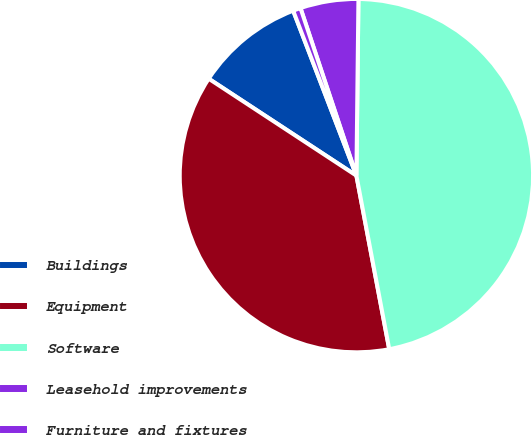<chart> <loc_0><loc_0><loc_500><loc_500><pie_chart><fcel>Buildings<fcel>Equipment<fcel>Software<fcel>Leasehold improvements<fcel>Furniture and fixtures<nl><fcel>9.93%<fcel>37.22%<fcel>46.84%<fcel>5.31%<fcel>0.7%<nl></chart> 